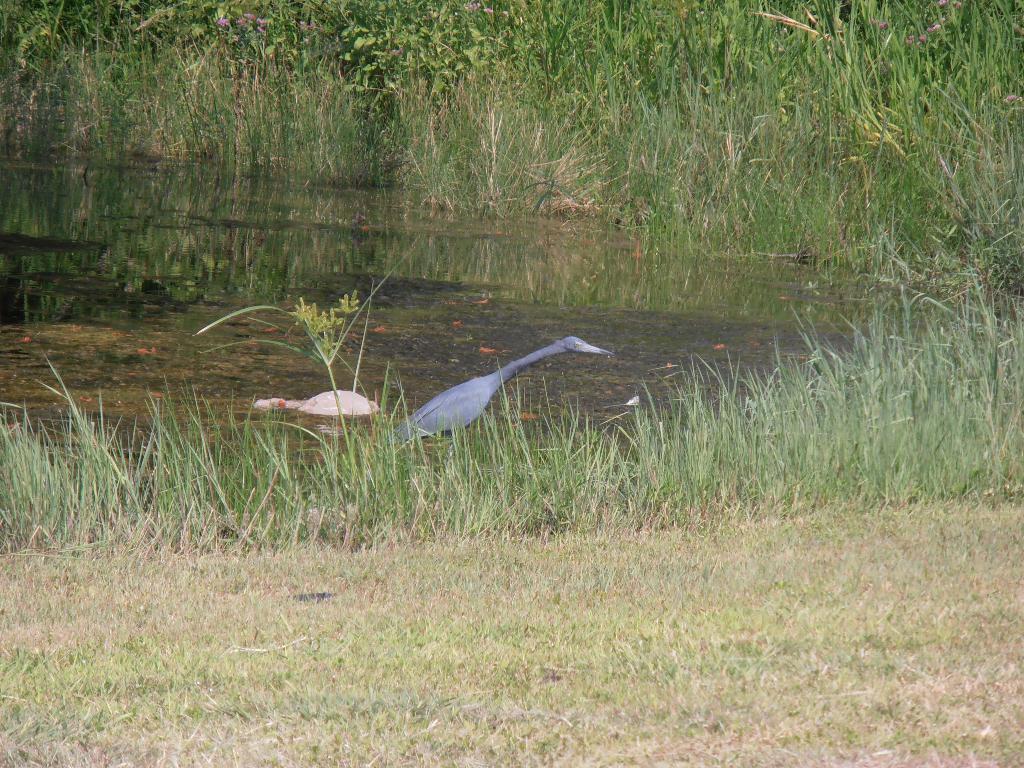Could you give a brief overview of what you see in this image? This image is the bottom there is grass, and in the center there is a pond. In the pond there is a bird and there might be a tortoise, and in the background there are plants and grass. 